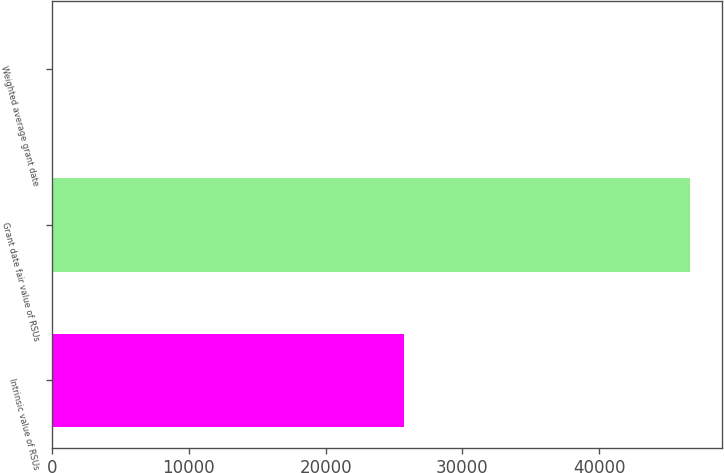<chart> <loc_0><loc_0><loc_500><loc_500><bar_chart><fcel>Intrinsic value of RSUs<fcel>Grant date fair value of RSUs<fcel>Weighted average grant date<nl><fcel>25727<fcel>46620<fcel>15.08<nl></chart> 